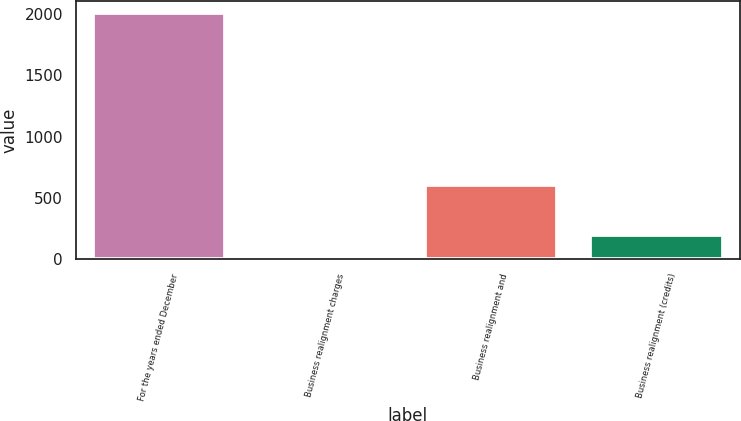Convert chart to OTSL. <chart><loc_0><loc_0><loc_500><loc_500><bar_chart><fcel>For the years ended December<fcel>Business realignment charges<fcel>Business realignment and<fcel>Business realignment (credits)<nl><fcel>2007<fcel>0.03<fcel>602.13<fcel>200.73<nl></chart> 